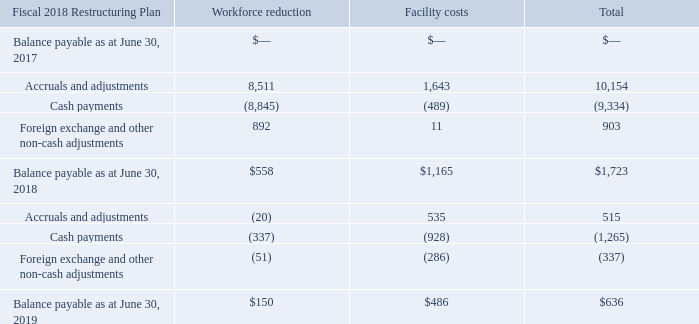Fiscal 2018 Restructuring Plan
During Fiscal 2018 and in the context of our acquisitions of Covisint, Guidance and Hightail (each defined below), we began to implement restructuring activities to streamline our operations (collectively referred to as the Fiscal 2018 Restructuring Plan). The Fiscal 2018 Restructuring Plan charges relate to workforce reductions and facility consolidations. These charges require management to make certain judgments and estimates regarding the amount and timing of restructuring charges or recoveries. Our estimated liability could change subsequent to its recognition, requiring adjustments to the expense and the liability recorded. On a quarterly basis, we conduct an evaluation of the related liabilities and expenses and revise our assumptions and estimates as appropriate.
Since the inception of the plan, approximately $10.7 million has been recorded within "Special charges (recoveries)" to date. We do not expect to incur any further significant charges relating to this plan.
A reconciliation of the beginning and ending liability for the year ended June 30, 2019 and 2018 is shown below.
What does the table show? Reconciliation of the beginning and ending liability for the year ended june 30, 2019 and 2018. How much has been  recorded within "Special charges (recoveries)" since the inception of the plan to date? $10.7 million. What is the Balance payable as at June 30, 2019 for workforce reduction?
Answer scale should be: thousand. 150. What is the Balance payable as at June 30, 2019 for Workforce reduction expressed as a percentage of total Balance payable as at June 30, 2019? 
Answer scale should be: percent. 150/636
Answer: 23.58. What is the difference between the total Balance payable as at June 30, 2019 vs that of 2018?
Answer scale should be: thousand. 636-1,723
Answer: -1087. For Balance payable as at June 30, 2019, What is the difference between Workforce reduction and Facility costs?
Answer scale should be: thousand. 150-486
Answer: -336. 